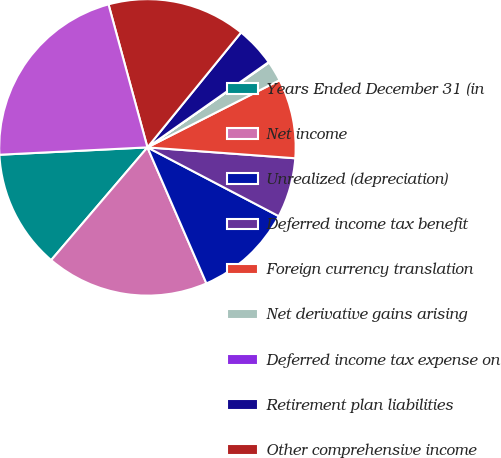Convert chart to OTSL. <chart><loc_0><loc_0><loc_500><loc_500><pie_chart><fcel>Years Ended December 31 (in<fcel>Net income<fcel>Unrealized (depreciation)<fcel>Deferred income tax benefit<fcel>Foreign currency translation<fcel>Net derivative gains arising<fcel>Deferred income tax expense on<fcel>Retirement plan liabilities<fcel>Other comprehensive income<fcel>Comprehensive income<nl><fcel>12.96%<fcel>17.76%<fcel>10.81%<fcel>6.51%<fcel>8.66%<fcel>2.21%<fcel>0.06%<fcel>4.36%<fcel>15.11%<fcel>21.56%<nl></chart> 